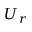<formula> <loc_0><loc_0><loc_500><loc_500>U _ { r }</formula> 